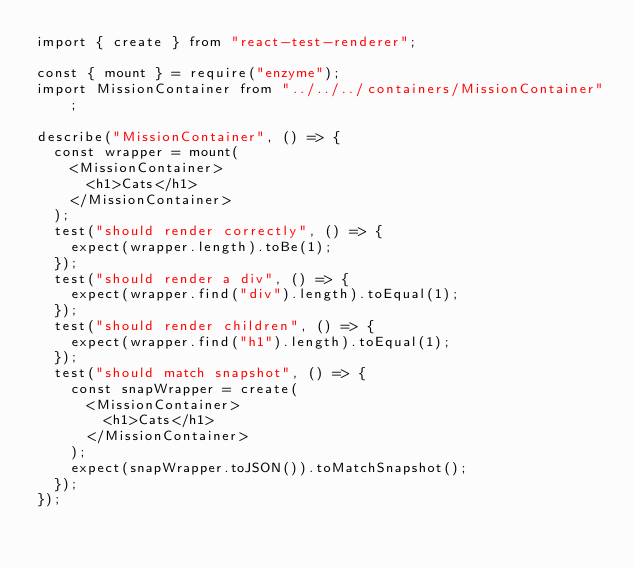<code> <loc_0><loc_0><loc_500><loc_500><_JavaScript_>import { create } from "react-test-renderer";

const { mount } = require("enzyme");
import MissionContainer from "../../../containers/MissionContainer";

describe("MissionContainer", () => {
  const wrapper = mount(
    <MissionContainer>
      <h1>Cats</h1>
    </MissionContainer>
  );
  test("should render correctly", () => {
    expect(wrapper.length).toBe(1);
  });
  test("should render a div", () => {
    expect(wrapper.find("div").length).toEqual(1);
  });
  test("should render children", () => {
    expect(wrapper.find("h1").length).toEqual(1);
  });
  test("should match snapshot", () => {
    const snapWrapper = create(
      <MissionContainer>
        <h1>Cats</h1>
      </MissionContainer>
    );
    expect(snapWrapper.toJSON()).toMatchSnapshot();
  });
});
</code> 